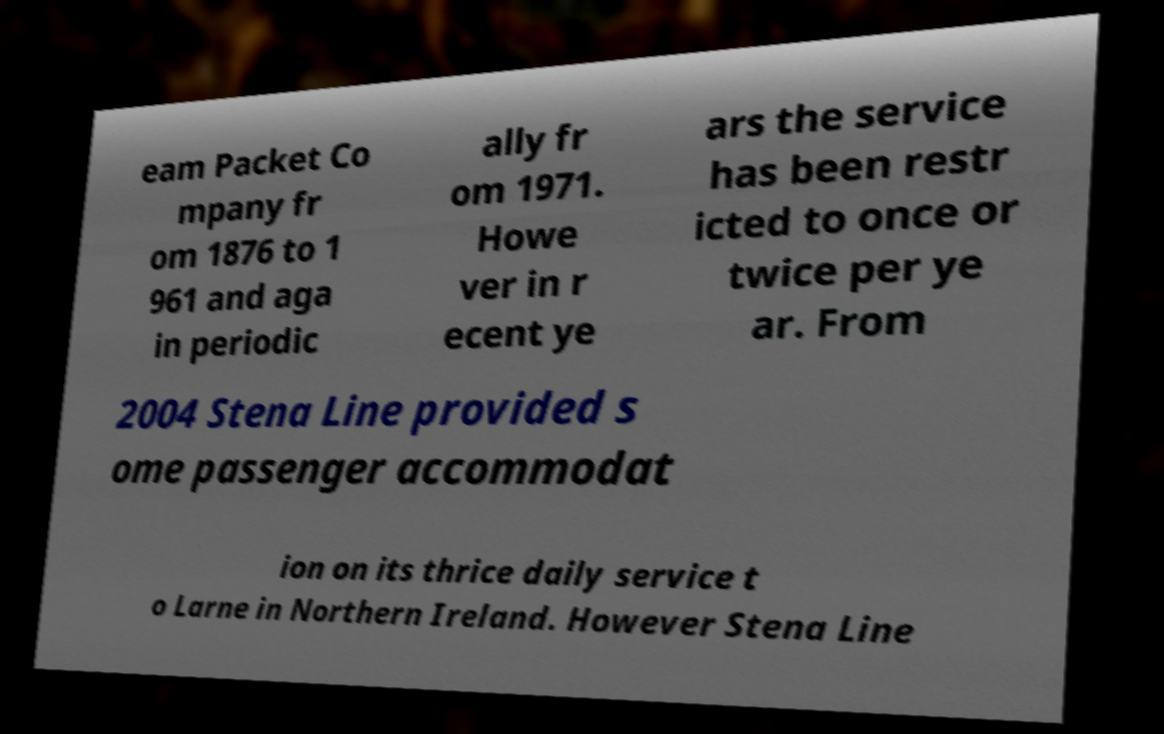What messages or text are displayed in this image? I need them in a readable, typed format. eam Packet Co mpany fr om 1876 to 1 961 and aga in periodic ally fr om 1971. Howe ver in r ecent ye ars the service has been restr icted to once or twice per ye ar. From 2004 Stena Line provided s ome passenger accommodat ion on its thrice daily service t o Larne in Northern Ireland. However Stena Line 